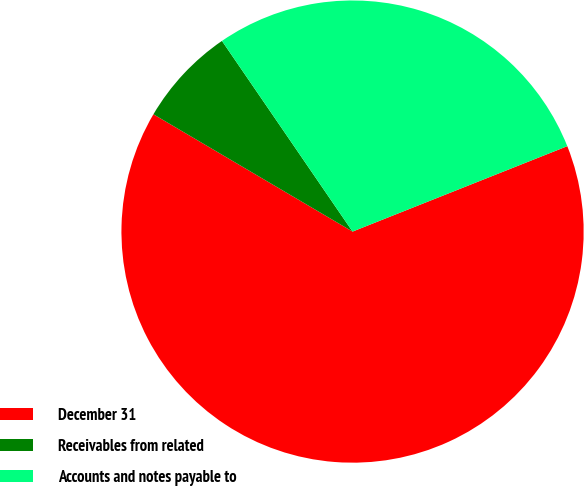<chart> <loc_0><loc_0><loc_500><loc_500><pie_chart><fcel>December 31<fcel>Receivables from related<fcel>Accounts and notes payable to<nl><fcel>64.49%<fcel>6.97%<fcel>28.53%<nl></chart> 